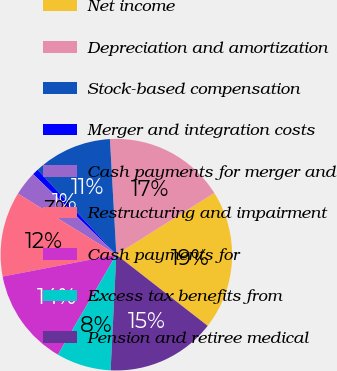Convert chart to OTSL. <chart><loc_0><loc_0><loc_500><loc_500><pie_chart><fcel>Net income<fcel>Depreciation and amortization<fcel>Stock-based compensation<fcel>Merger and integration costs<fcel>Cash payments for merger and<fcel>Restructuring and impairment<fcel>Cash payments for<fcel>Excess tax benefits from<fcel>Pension and retiree medical<nl><fcel>19.48%<fcel>16.94%<fcel>11.02%<fcel>0.86%<fcel>3.4%<fcel>11.86%<fcel>13.56%<fcel>7.63%<fcel>15.25%<nl></chart> 